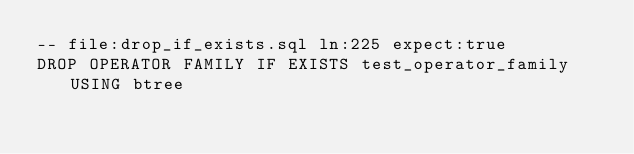<code> <loc_0><loc_0><loc_500><loc_500><_SQL_>-- file:drop_if_exists.sql ln:225 expect:true
DROP OPERATOR FAMILY IF EXISTS test_operator_family USING btree
</code> 